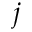Convert formula to latex. <formula><loc_0><loc_0><loc_500><loc_500>j</formula> 